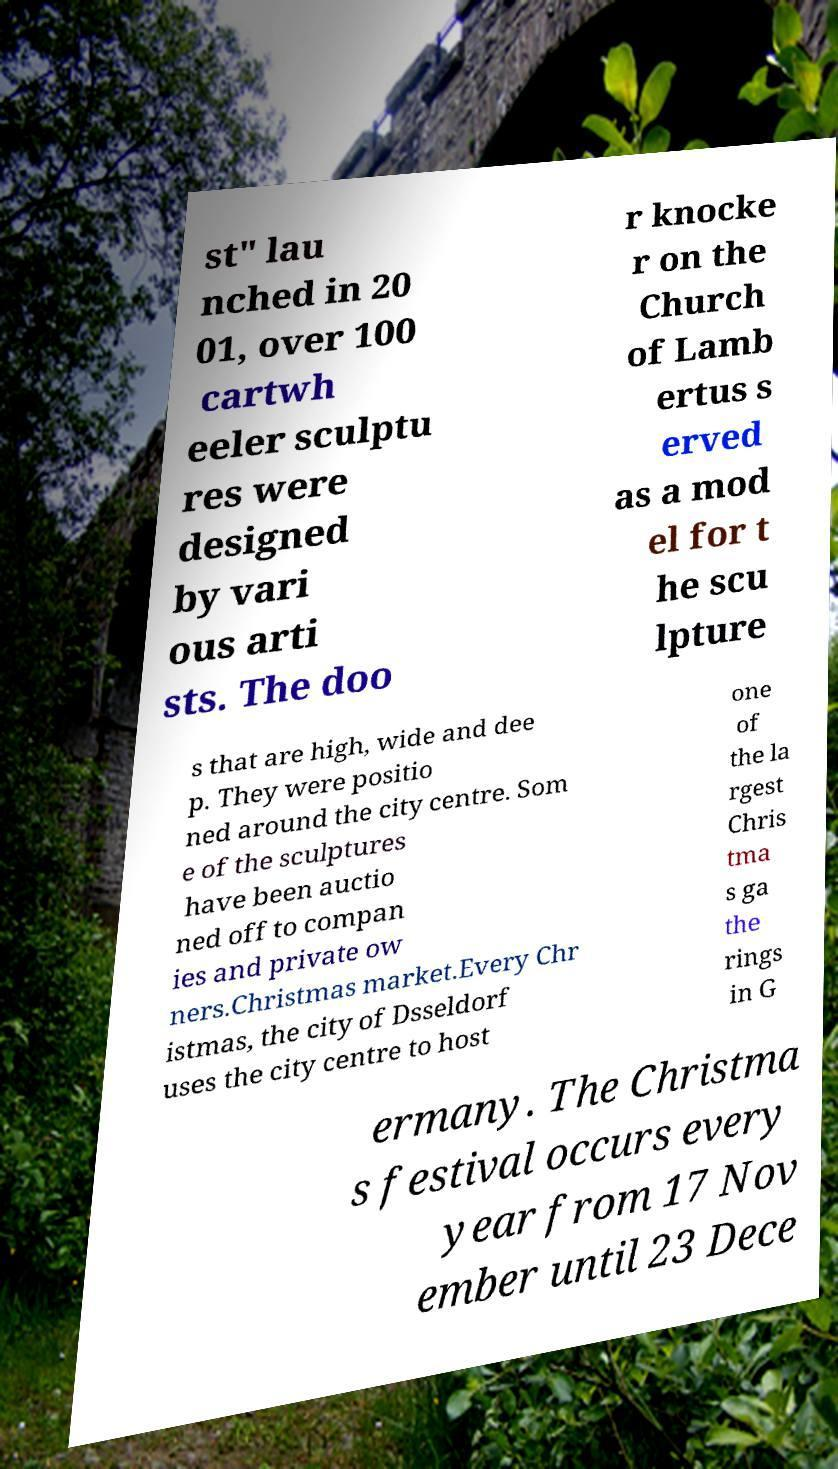Please identify and transcribe the text found in this image. st" lau nched in 20 01, over 100 cartwh eeler sculptu res were designed by vari ous arti sts. The doo r knocke r on the Church of Lamb ertus s erved as a mod el for t he scu lpture s that are high, wide and dee p. They were positio ned around the city centre. Som e of the sculptures have been auctio ned off to compan ies and private ow ners.Christmas market.Every Chr istmas, the city of Dsseldorf uses the city centre to host one of the la rgest Chris tma s ga the rings in G ermany. The Christma s festival occurs every year from 17 Nov ember until 23 Dece 